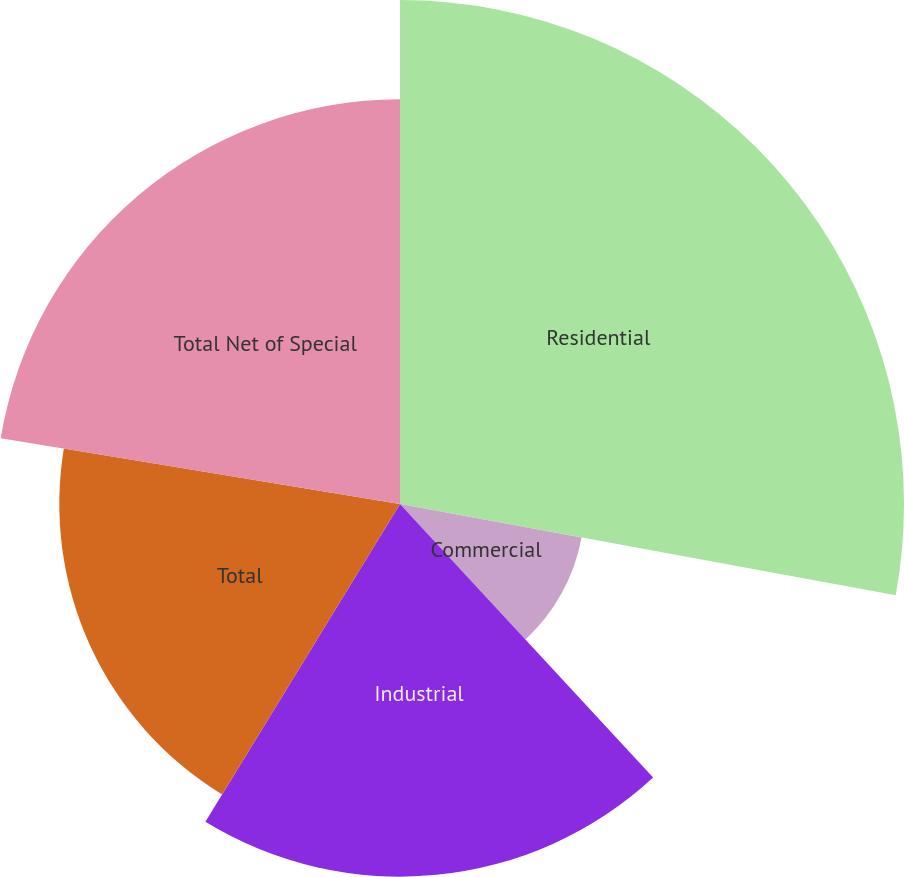<chart> <loc_0><loc_0><loc_500><loc_500><pie_chart><fcel>Residential<fcel>Commercial<fcel>Industrial<fcel>Total<fcel>Total Net of Special<nl><fcel>27.9%<fcel>10.22%<fcel>20.63%<fcel>18.86%<fcel>22.4%<nl></chart> 